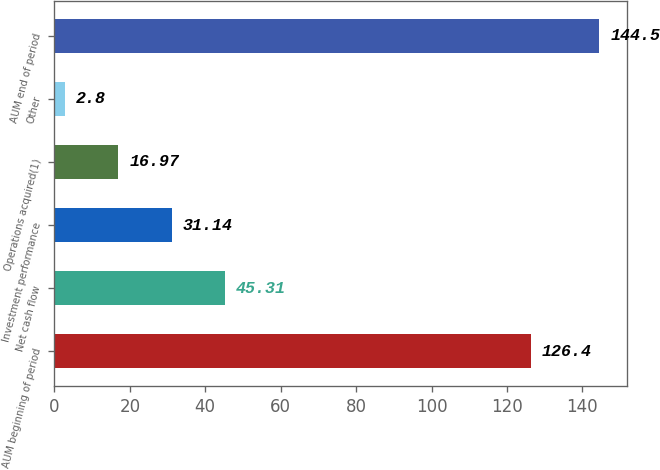Convert chart to OTSL. <chart><loc_0><loc_0><loc_500><loc_500><bar_chart><fcel>AUM beginning of period<fcel>Net cash flow<fcel>Investment performance<fcel>Operations acquired(1)<fcel>Other<fcel>AUM end of period<nl><fcel>126.4<fcel>45.31<fcel>31.14<fcel>16.97<fcel>2.8<fcel>144.5<nl></chart> 